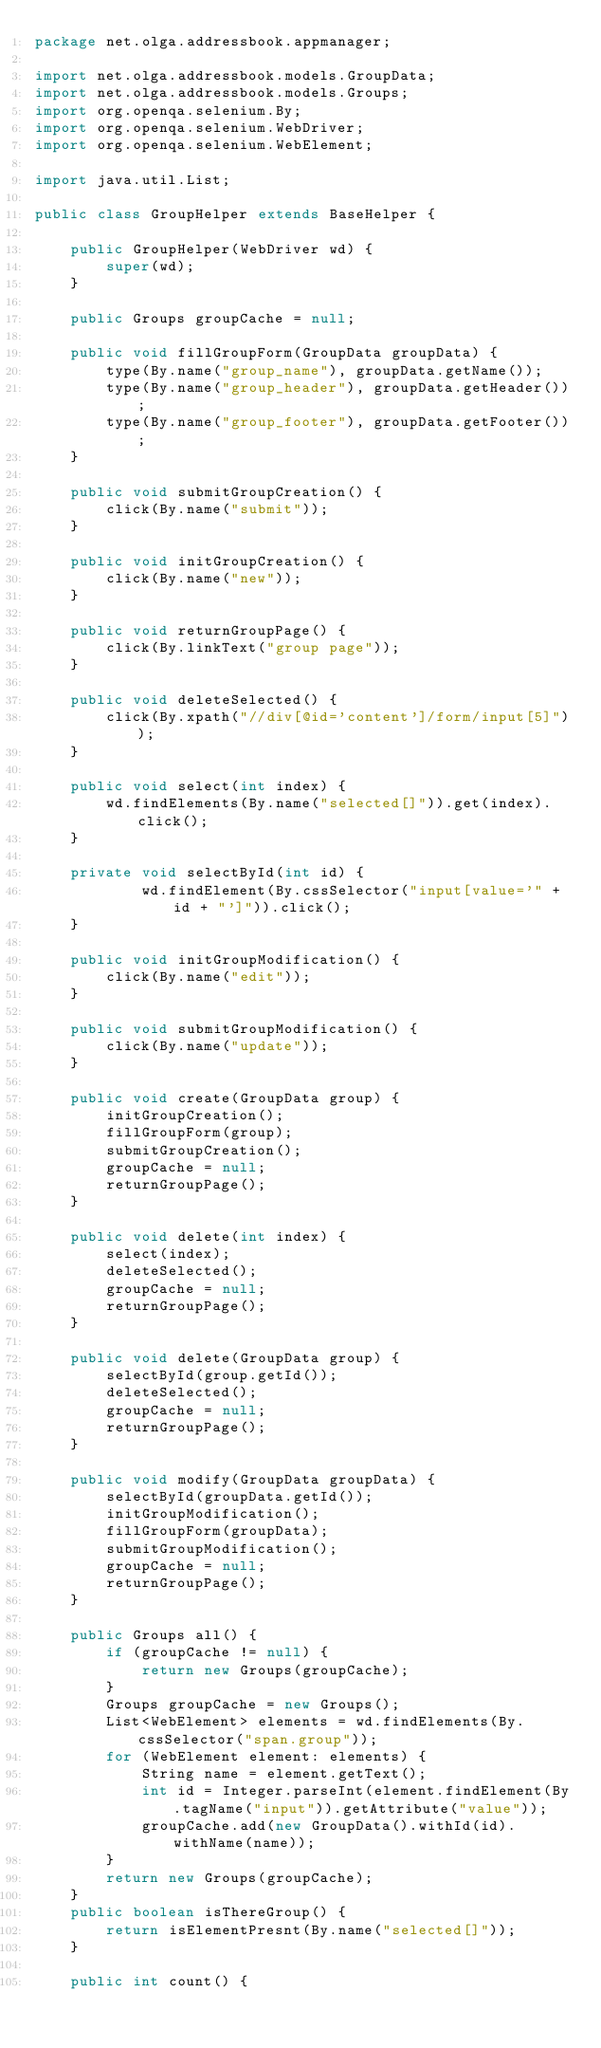Convert code to text. <code><loc_0><loc_0><loc_500><loc_500><_Java_>package net.olga.addressbook.appmanager;

import net.olga.addressbook.models.GroupData;
import net.olga.addressbook.models.Groups;
import org.openqa.selenium.By;
import org.openqa.selenium.WebDriver;
import org.openqa.selenium.WebElement;

import java.util.List;

public class GroupHelper extends BaseHelper {

    public GroupHelper(WebDriver wd) {
        super(wd);
    }

    public Groups groupCache = null;

    public void fillGroupForm(GroupData groupData) {
        type(By.name("group_name"), groupData.getName());
        type(By.name("group_header"), groupData.getHeader());
        type(By.name("group_footer"), groupData.getFooter());
    }

    public void submitGroupCreation() {
        click(By.name("submit"));
    }

    public void initGroupCreation() {
        click(By.name("new"));
    }

    public void returnGroupPage() {
        click(By.linkText("group page"));
    }

    public void deleteSelected() {
        click(By.xpath("//div[@id='content']/form/input[5]"));
    }

    public void select(int index) {
        wd.findElements(By.name("selected[]")).get(index).click();
    }

    private void selectById(int id) {
            wd.findElement(By.cssSelector("input[value='" + id + "']")).click();
    }

    public void initGroupModification() {
        click(By.name("edit"));
    }

    public void submitGroupModification() {
        click(By.name("update"));
    }

    public void create(GroupData group) {
        initGroupCreation();
        fillGroupForm(group);
        submitGroupCreation();
        groupCache = null;
        returnGroupPage();
    }

    public void delete(int index) {
        select(index);
        deleteSelected();
        groupCache = null;
        returnGroupPage();
    }

    public void delete(GroupData group) {
        selectById(group.getId());
        deleteSelected();
        groupCache = null;
        returnGroupPage();
    }

    public void modify(GroupData groupData) {
        selectById(groupData.getId());
        initGroupModification();
        fillGroupForm(groupData);
        submitGroupModification();
        groupCache = null;
        returnGroupPage();
    }

    public Groups all() {
        if (groupCache != null) {
            return new Groups(groupCache);
        }
        Groups groupCache = new Groups();
        List<WebElement> elements = wd.findElements(By.cssSelector("span.group"));
        for (WebElement element: elements) {
            String name = element.getText();
            int id = Integer.parseInt(element.findElement(By.tagName("input")).getAttribute("value"));
            groupCache.add(new GroupData().withId(id).withName(name));
        }
        return new Groups(groupCache);
    }
    public boolean isThereGroup() {
        return isElementPresnt(By.name("selected[]"));
    }

    public int count() {</code> 